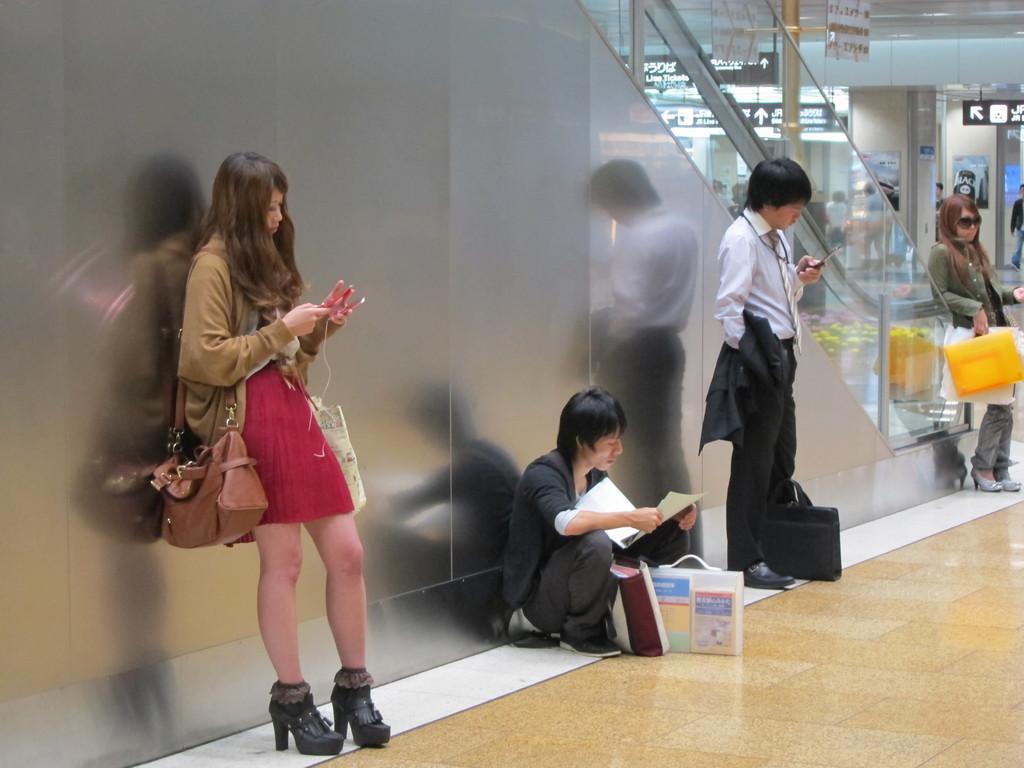In one or two sentences, can you explain what this image depicts? Here in this picture we can see some people standing on the floor over there and in the middle we can see a person sitting and the women on either side are carrying handbags with them and in the middle we can see the men with bags in front of them and behind them we can see an escalator present and in the far we can see sign boards present over there. 